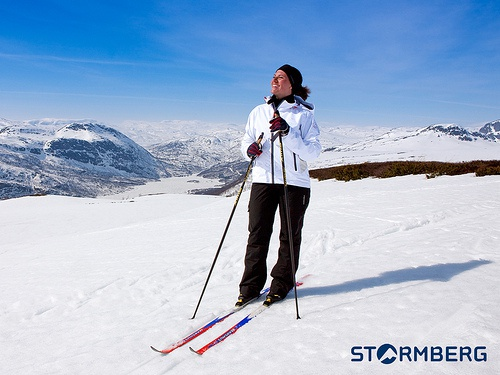Describe the objects in this image and their specific colors. I can see people in blue, black, lavender, and darkgray tones, skis in blue, lightgray, black, red, and lightpink tones, and skis in blue, lightgray, red, darkblue, and darkgray tones in this image. 